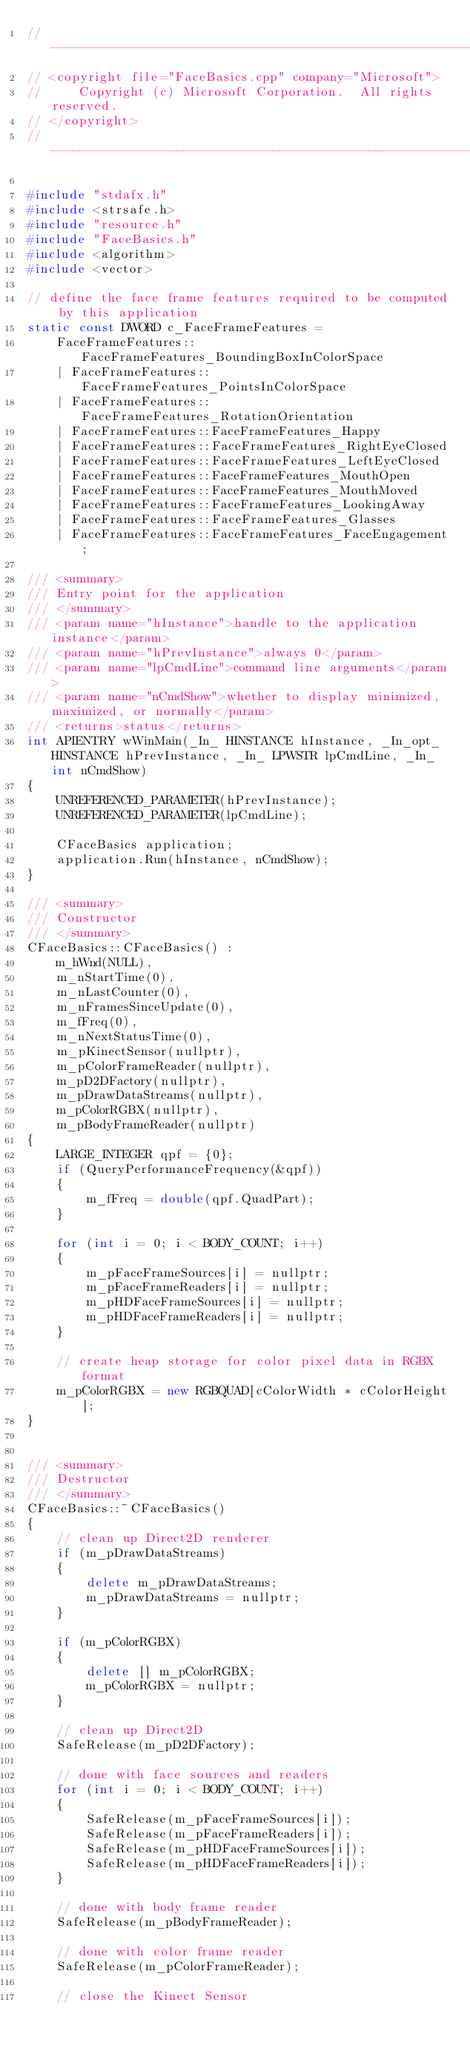Convert code to text. <code><loc_0><loc_0><loc_500><loc_500><_C++_>//------------------------------------------------------------------------------
// <copyright file="FaceBasics.cpp" company="Microsoft">
//     Copyright (c) Microsoft Corporation.  All rights reserved.
// </copyright>
//------------------------------------------------------------------------------

#include "stdafx.h"
#include <strsafe.h>
#include "resource.h"
#include "FaceBasics.h"
#include <algorithm>
#include <vector>

// define the face frame features required to be computed by this application
static const DWORD c_FaceFrameFeatures = 
    FaceFrameFeatures::FaceFrameFeatures_BoundingBoxInColorSpace
    | FaceFrameFeatures::FaceFrameFeatures_PointsInColorSpace
    | FaceFrameFeatures::FaceFrameFeatures_RotationOrientation
    | FaceFrameFeatures::FaceFrameFeatures_Happy
    | FaceFrameFeatures::FaceFrameFeatures_RightEyeClosed
    | FaceFrameFeatures::FaceFrameFeatures_LeftEyeClosed
    | FaceFrameFeatures::FaceFrameFeatures_MouthOpen
    | FaceFrameFeatures::FaceFrameFeatures_MouthMoved
    | FaceFrameFeatures::FaceFrameFeatures_LookingAway
    | FaceFrameFeatures::FaceFrameFeatures_Glasses
    | FaceFrameFeatures::FaceFrameFeatures_FaceEngagement;

/// <summary>
/// Entry point for the application
/// </summary>
/// <param name="hInstance">handle to the application instance</param>
/// <param name="hPrevInstance">always 0</param>
/// <param name="lpCmdLine">command line arguments</param>
/// <param name="nCmdShow">whether to display minimized, maximized, or normally</param>
/// <returns>status</returns>
int APIENTRY wWinMain(_In_ HINSTANCE hInstance, _In_opt_ HINSTANCE hPrevInstance, _In_ LPWSTR lpCmdLine, _In_ int nCmdShow)
{
    UNREFERENCED_PARAMETER(hPrevInstance);
    UNREFERENCED_PARAMETER(lpCmdLine);
    
    CFaceBasics application;
    application.Run(hInstance, nCmdShow);
}

/// <summary>
/// Constructor
/// </summary>
CFaceBasics::CFaceBasics() :
    m_hWnd(NULL),
    m_nStartTime(0),
    m_nLastCounter(0),
    m_nFramesSinceUpdate(0),
    m_fFreq(0),
    m_nNextStatusTime(0),
    m_pKinectSensor(nullptr),
    m_pColorFrameReader(nullptr),
    m_pD2DFactory(nullptr),
    m_pDrawDataStreams(nullptr),
    m_pColorRGBX(nullptr),
    m_pBodyFrameReader(nullptr)	
{
    LARGE_INTEGER qpf = {0};
    if (QueryPerformanceFrequency(&qpf))
    {
        m_fFreq = double(qpf.QuadPart);
    }

    for (int i = 0; i < BODY_COUNT; i++)
    {
        m_pFaceFrameSources[i] = nullptr;
        m_pFaceFrameReaders[i] = nullptr;
		m_pHDFaceFrameSources[i] = nullptr;
		m_pHDFaceFrameReaders[i] = nullptr;
    }

    // create heap storage for color pixel data in RGBX format
    m_pColorRGBX = new RGBQUAD[cColorWidth * cColorHeight];
}


/// <summary>
/// Destructor
/// </summary>
CFaceBasics::~CFaceBasics()
{
    // clean up Direct2D renderer
    if (m_pDrawDataStreams)
    {
        delete m_pDrawDataStreams;
        m_pDrawDataStreams = nullptr;
    }

    if (m_pColorRGBX)
    {
        delete [] m_pColorRGBX;
        m_pColorRGBX = nullptr;
    }

    // clean up Direct2D
    SafeRelease(m_pD2DFactory);

    // done with face sources and readers
    for (int i = 0; i < BODY_COUNT; i++)
    {
        SafeRelease(m_pFaceFrameSources[i]);
        SafeRelease(m_pFaceFrameReaders[i]);		
		SafeRelease(m_pHDFaceFrameSources[i]);
		SafeRelease(m_pHDFaceFrameReaders[i]);
    }

    // done with body frame reader
    SafeRelease(m_pBodyFrameReader);

    // done with color frame reader
    SafeRelease(m_pColorFrameReader);

    // close the Kinect Sensor</code> 